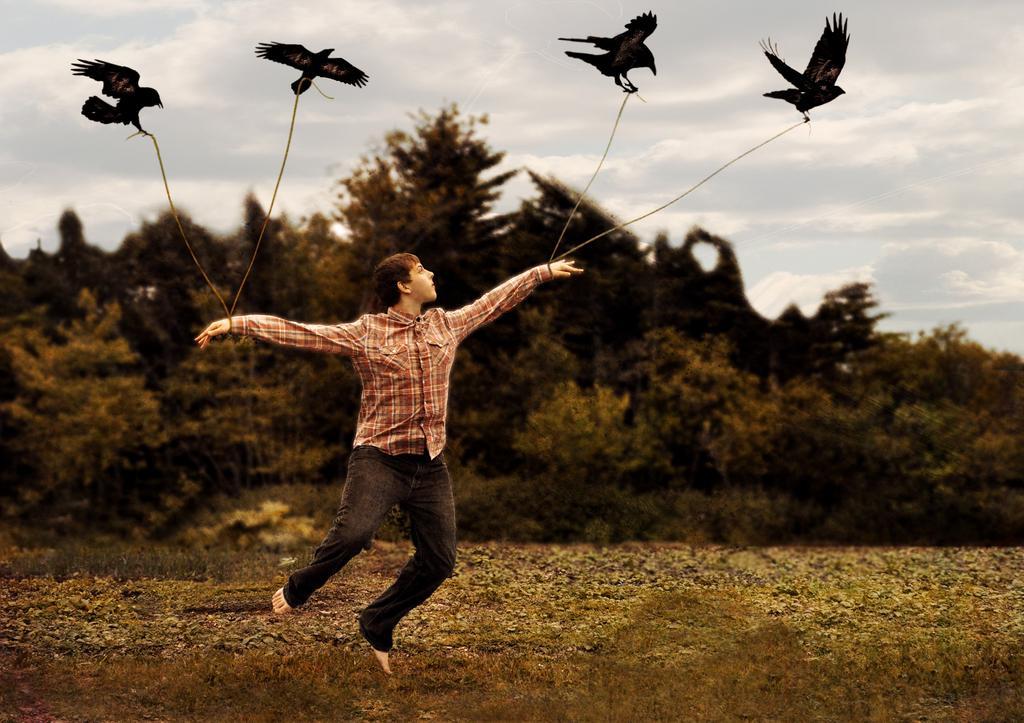Describe this image in one or two sentences. In this image we can see a person. There are few birds in the image. We can see the clouds in the sky. There are many trees and plants in the image. 